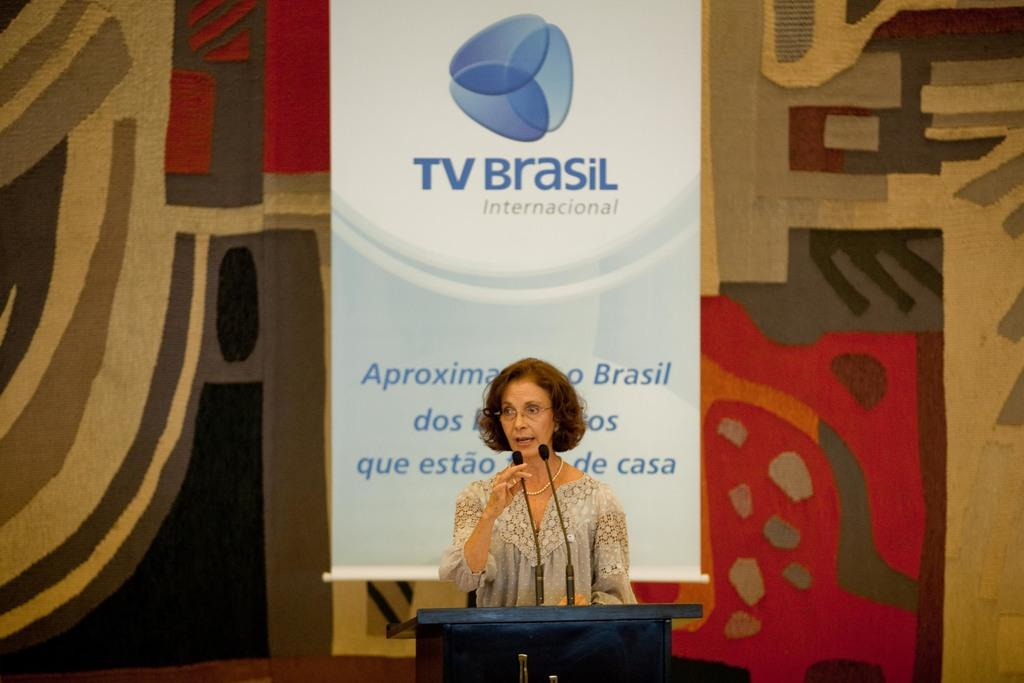<image>
Give a short and clear explanation of the subsequent image. a woman standing in front of a banner titled 'tv brasil' 